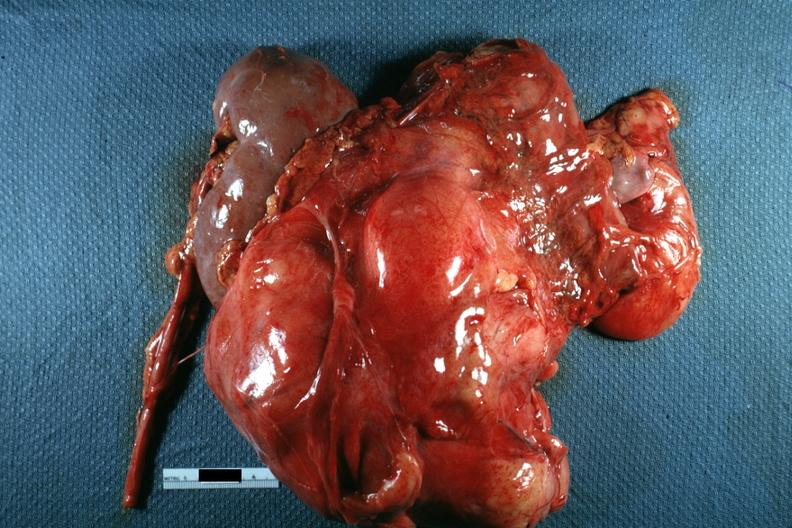where is this area in the body?
Answer the question using a single word or phrase. Abdomen 